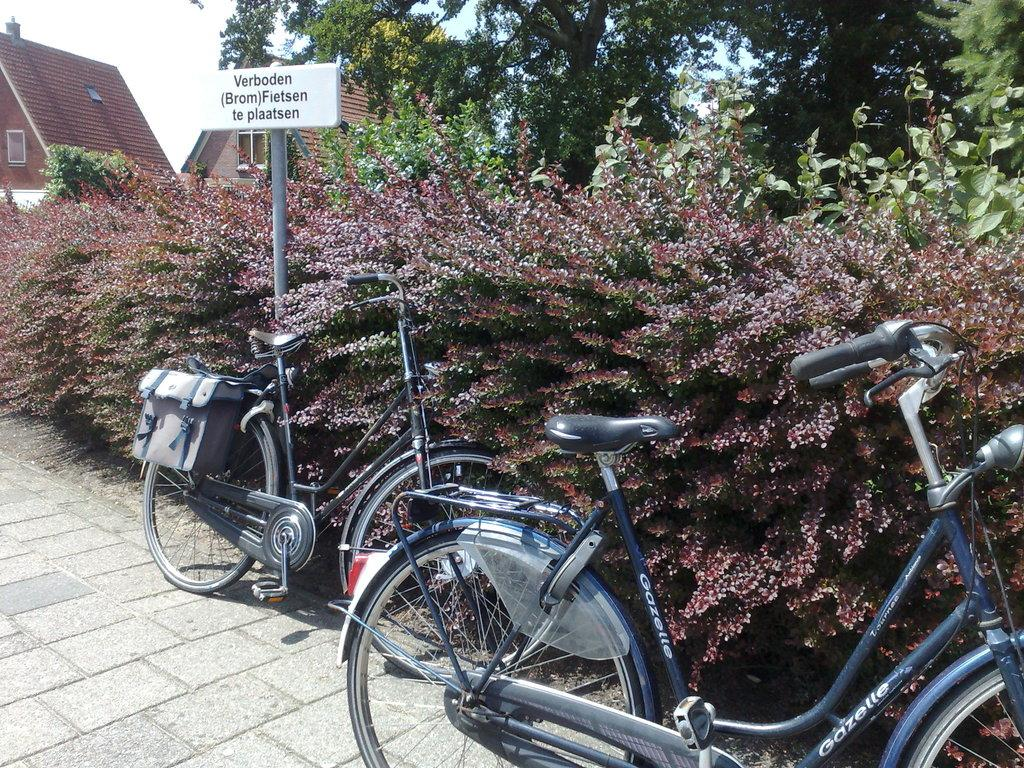What objects are on the ground in the image? There are bicycles on the ground in the image. What can be seen in the background of the image? There is a name board, trees, houses, and the sky visible in the background of the image. How many mice can be seen running around the bicycles in the image? There are no mice present in the image; it only features bicycles on the ground. What type of destruction can be seen in the image? There is no destruction present in the image; it is a peaceful scene with bicycles on the ground and a background featuring a name board, trees, houses, and the sky. 